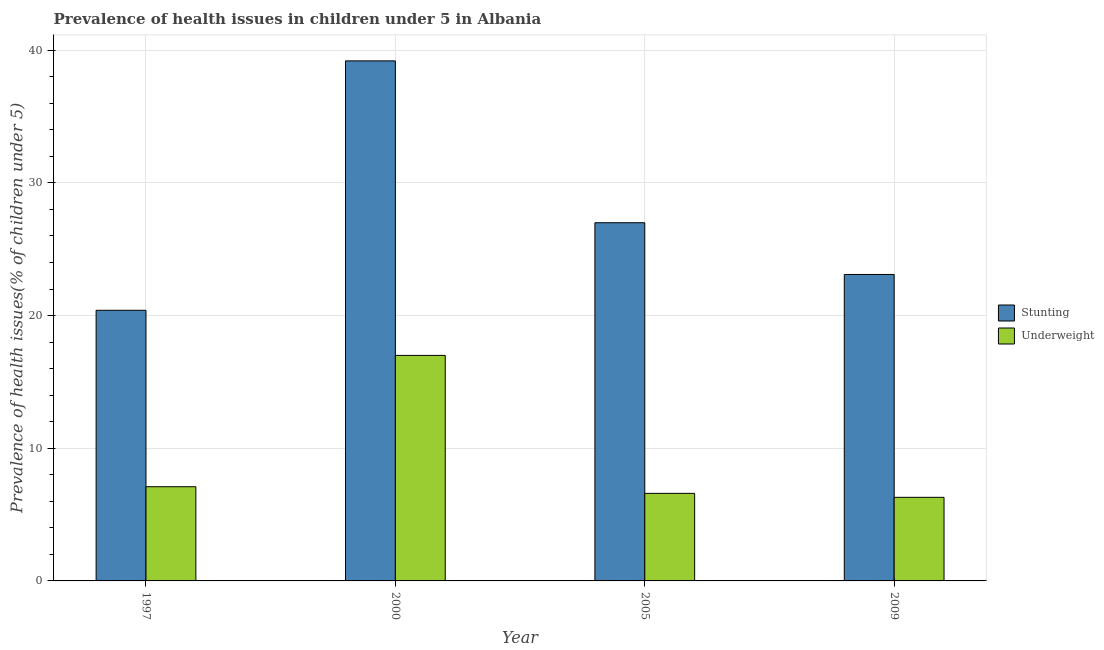Are the number of bars per tick equal to the number of legend labels?
Keep it short and to the point. Yes. Are the number of bars on each tick of the X-axis equal?
Keep it short and to the point. Yes. How many bars are there on the 4th tick from the left?
Your answer should be very brief. 2. What is the label of the 2nd group of bars from the left?
Keep it short and to the point. 2000. What is the percentage of stunted children in 2000?
Your response must be concise. 39.2. Across all years, what is the maximum percentage of stunted children?
Your response must be concise. 39.2. Across all years, what is the minimum percentage of underweight children?
Keep it short and to the point. 6.3. In which year was the percentage of underweight children minimum?
Your response must be concise. 2009. What is the total percentage of stunted children in the graph?
Make the answer very short. 109.7. What is the difference between the percentage of stunted children in 2005 and that in 2009?
Your response must be concise. 3.9. What is the difference between the percentage of stunted children in 1997 and the percentage of underweight children in 2005?
Your answer should be very brief. -6.6. What is the average percentage of stunted children per year?
Your answer should be very brief. 27.43. In how many years, is the percentage of underweight children greater than 32 %?
Ensure brevity in your answer.  0. What is the ratio of the percentage of stunted children in 2000 to that in 2005?
Keep it short and to the point. 1.45. Is the percentage of stunted children in 2000 less than that in 2009?
Keep it short and to the point. No. Is the difference between the percentage of stunted children in 1997 and 2009 greater than the difference between the percentage of underweight children in 1997 and 2009?
Give a very brief answer. No. What is the difference between the highest and the second highest percentage of stunted children?
Ensure brevity in your answer.  12.2. What is the difference between the highest and the lowest percentage of stunted children?
Offer a terse response. 18.8. Is the sum of the percentage of stunted children in 1997 and 2009 greater than the maximum percentage of underweight children across all years?
Provide a succinct answer. Yes. What does the 1st bar from the left in 2005 represents?
Keep it short and to the point. Stunting. What does the 1st bar from the right in 1997 represents?
Offer a terse response. Underweight. Are all the bars in the graph horizontal?
Ensure brevity in your answer.  No. How many years are there in the graph?
Your answer should be compact. 4. What is the difference between two consecutive major ticks on the Y-axis?
Your answer should be very brief. 10. Are the values on the major ticks of Y-axis written in scientific E-notation?
Provide a succinct answer. No. What is the title of the graph?
Offer a very short reply. Prevalence of health issues in children under 5 in Albania. What is the label or title of the Y-axis?
Your answer should be very brief. Prevalence of health issues(% of children under 5). What is the Prevalence of health issues(% of children under 5) in Stunting in 1997?
Your response must be concise. 20.4. What is the Prevalence of health issues(% of children under 5) of Underweight in 1997?
Provide a short and direct response. 7.1. What is the Prevalence of health issues(% of children under 5) of Stunting in 2000?
Your answer should be very brief. 39.2. What is the Prevalence of health issues(% of children under 5) of Underweight in 2005?
Your answer should be compact. 6.6. What is the Prevalence of health issues(% of children under 5) of Stunting in 2009?
Offer a very short reply. 23.1. What is the Prevalence of health issues(% of children under 5) in Underweight in 2009?
Provide a short and direct response. 6.3. Across all years, what is the maximum Prevalence of health issues(% of children under 5) in Stunting?
Your answer should be compact. 39.2. Across all years, what is the maximum Prevalence of health issues(% of children under 5) in Underweight?
Provide a short and direct response. 17. Across all years, what is the minimum Prevalence of health issues(% of children under 5) in Stunting?
Ensure brevity in your answer.  20.4. Across all years, what is the minimum Prevalence of health issues(% of children under 5) of Underweight?
Provide a short and direct response. 6.3. What is the total Prevalence of health issues(% of children under 5) in Stunting in the graph?
Provide a short and direct response. 109.7. What is the difference between the Prevalence of health issues(% of children under 5) in Stunting in 1997 and that in 2000?
Make the answer very short. -18.8. What is the difference between the Prevalence of health issues(% of children under 5) of Underweight in 1997 and that in 2000?
Offer a terse response. -9.9. What is the difference between the Prevalence of health issues(% of children under 5) of Stunting in 2000 and that in 2005?
Make the answer very short. 12.2. What is the difference between the Prevalence of health issues(% of children under 5) in Underweight in 2000 and that in 2005?
Provide a short and direct response. 10.4. What is the difference between the Prevalence of health issues(% of children under 5) of Stunting in 2005 and that in 2009?
Your response must be concise. 3.9. What is the difference between the Prevalence of health issues(% of children under 5) of Stunting in 1997 and the Prevalence of health issues(% of children under 5) of Underweight in 2000?
Give a very brief answer. 3.4. What is the difference between the Prevalence of health issues(% of children under 5) in Stunting in 1997 and the Prevalence of health issues(% of children under 5) in Underweight in 2005?
Offer a very short reply. 13.8. What is the difference between the Prevalence of health issues(% of children under 5) of Stunting in 1997 and the Prevalence of health issues(% of children under 5) of Underweight in 2009?
Keep it short and to the point. 14.1. What is the difference between the Prevalence of health issues(% of children under 5) of Stunting in 2000 and the Prevalence of health issues(% of children under 5) of Underweight in 2005?
Offer a very short reply. 32.6. What is the difference between the Prevalence of health issues(% of children under 5) of Stunting in 2000 and the Prevalence of health issues(% of children under 5) of Underweight in 2009?
Your response must be concise. 32.9. What is the difference between the Prevalence of health issues(% of children under 5) of Stunting in 2005 and the Prevalence of health issues(% of children under 5) of Underweight in 2009?
Keep it short and to the point. 20.7. What is the average Prevalence of health issues(% of children under 5) in Stunting per year?
Offer a very short reply. 27.43. What is the average Prevalence of health issues(% of children under 5) of Underweight per year?
Your answer should be compact. 9.25. In the year 2000, what is the difference between the Prevalence of health issues(% of children under 5) in Stunting and Prevalence of health issues(% of children under 5) in Underweight?
Give a very brief answer. 22.2. In the year 2005, what is the difference between the Prevalence of health issues(% of children under 5) of Stunting and Prevalence of health issues(% of children under 5) of Underweight?
Offer a very short reply. 20.4. In the year 2009, what is the difference between the Prevalence of health issues(% of children under 5) of Stunting and Prevalence of health issues(% of children under 5) of Underweight?
Keep it short and to the point. 16.8. What is the ratio of the Prevalence of health issues(% of children under 5) of Stunting in 1997 to that in 2000?
Make the answer very short. 0.52. What is the ratio of the Prevalence of health issues(% of children under 5) of Underweight in 1997 to that in 2000?
Ensure brevity in your answer.  0.42. What is the ratio of the Prevalence of health issues(% of children under 5) in Stunting in 1997 to that in 2005?
Your answer should be compact. 0.76. What is the ratio of the Prevalence of health issues(% of children under 5) in Underweight in 1997 to that in 2005?
Give a very brief answer. 1.08. What is the ratio of the Prevalence of health issues(% of children under 5) of Stunting in 1997 to that in 2009?
Provide a short and direct response. 0.88. What is the ratio of the Prevalence of health issues(% of children under 5) of Underweight in 1997 to that in 2009?
Your answer should be compact. 1.13. What is the ratio of the Prevalence of health issues(% of children under 5) of Stunting in 2000 to that in 2005?
Your answer should be compact. 1.45. What is the ratio of the Prevalence of health issues(% of children under 5) in Underweight in 2000 to that in 2005?
Provide a succinct answer. 2.58. What is the ratio of the Prevalence of health issues(% of children under 5) in Stunting in 2000 to that in 2009?
Offer a terse response. 1.7. What is the ratio of the Prevalence of health issues(% of children under 5) of Underweight in 2000 to that in 2009?
Make the answer very short. 2.7. What is the ratio of the Prevalence of health issues(% of children under 5) of Stunting in 2005 to that in 2009?
Offer a very short reply. 1.17. What is the ratio of the Prevalence of health issues(% of children under 5) of Underweight in 2005 to that in 2009?
Offer a very short reply. 1.05. What is the difference between the highest and the second highest Prevalence of health issues(% of children under 5) in Underweight?
Provide a succinct answer. 9.9. What is the difference between the highest and the lowest Prevalence of health issues(% of children under 5) in Stunting?
Offer a very short reply. 18.8. What is the difference between the highest and the lowest Prevalence of health issues(% of children under 5) in Underweight?
Provide a succinct answer. 10.7. 